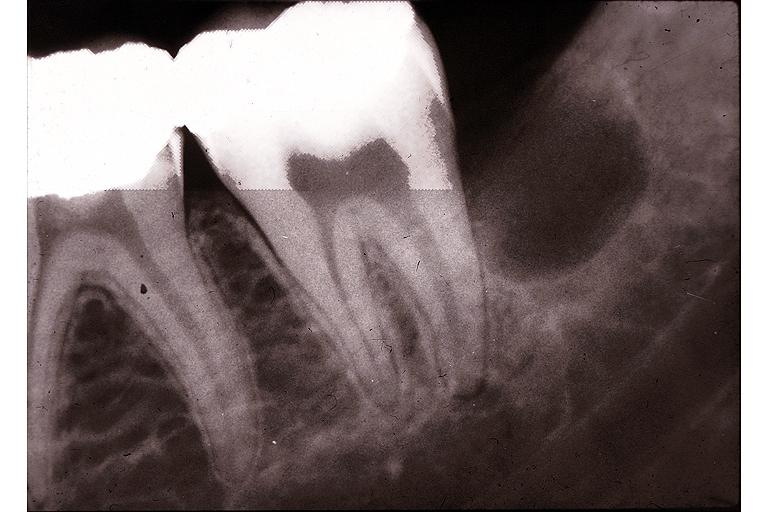s oral present?
Answer the question using a single word or phrase. Yes 